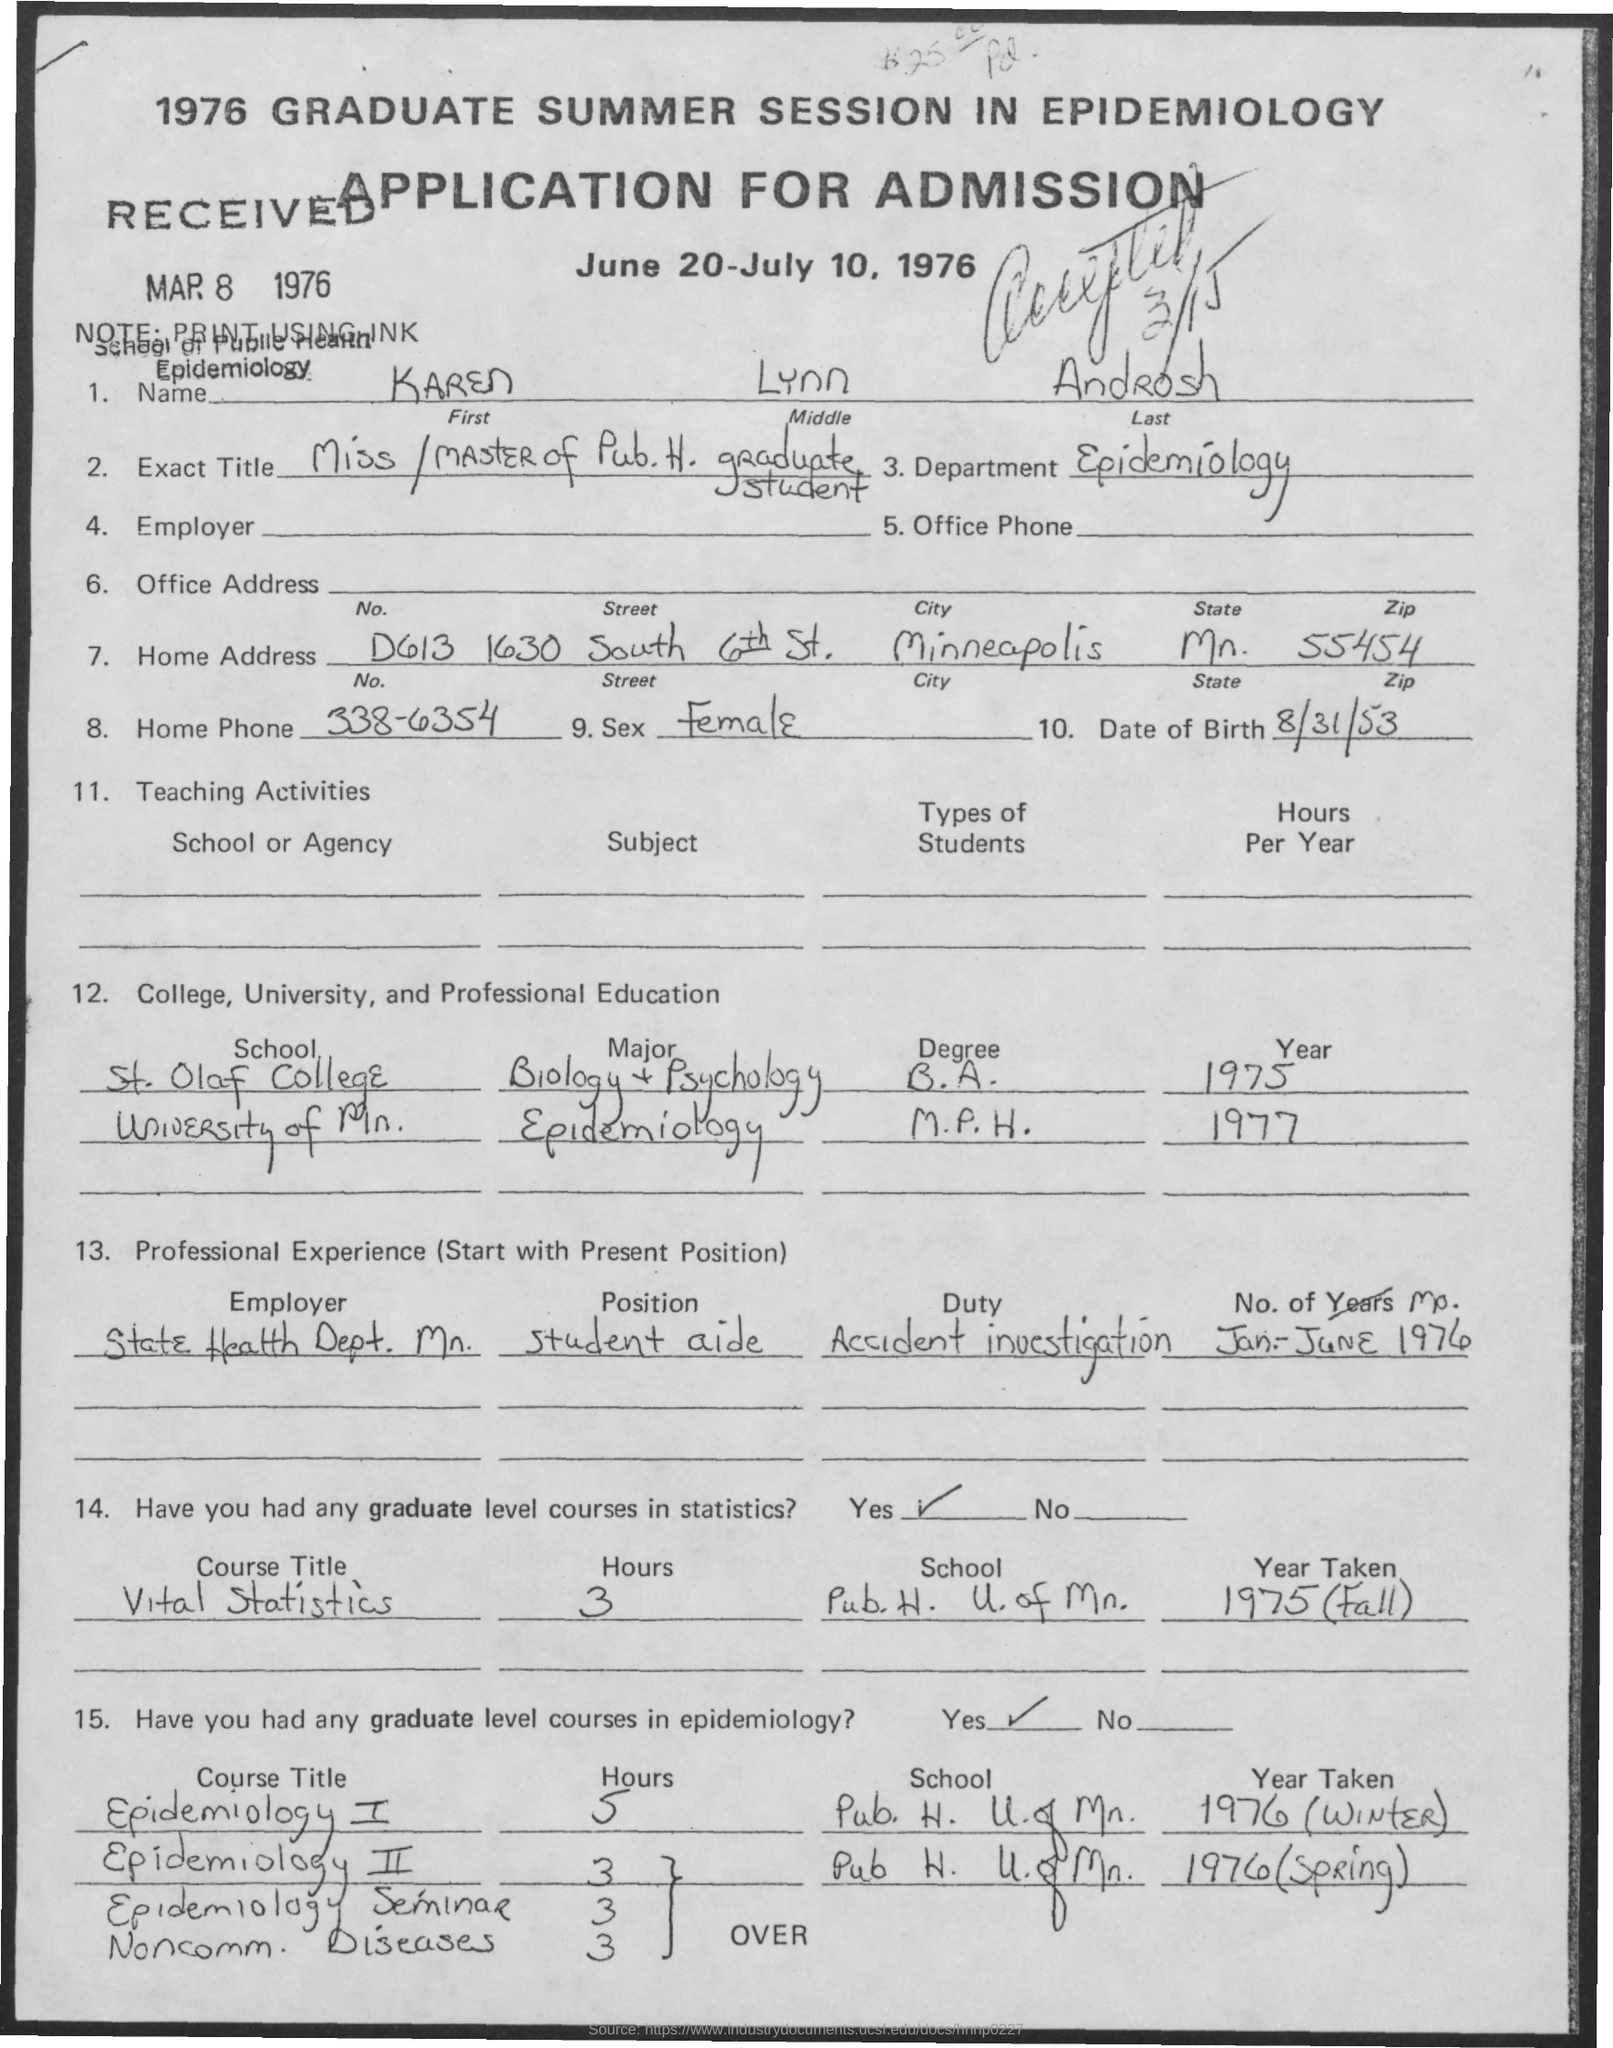What is the Middle Name of the person mentioned in the application form?
Give a very brief answer. Lynn. Which department is mentioned in the application?
Offer a very short reply. Epidemiology. What is the Home Phone no of Karen Lynn Androsh as given in the application?
Make the answer very short. 338-6354. What is the Date of Birth of Karen Lynn Androsh?
Provide a succinct answer. 8/31/53. What is the zipcode mentioned in this application?
Offer a terse response. 55454. Which city is mentioned in the home address of the application?
Make the answer very short. Minneapolis. Which year Karen Lynn Androsh has completed M.P.H. Degree in Epidemiology?
Provide a succinct answer. 1977. What was the duty assigned to Karen Lynn Androsh as a student aide in State Health Dept. Mn.?
Provide a short and direct response. Accident investigation. 